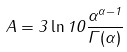Convert formula to latex. <formula><loc_0><loc_0><loc_500><loc_500>A = 3 \ln 1 0 \frac { \alpha ^ { \alpha - 1 } } { \Gamma ( \alpha ) }</formula> 